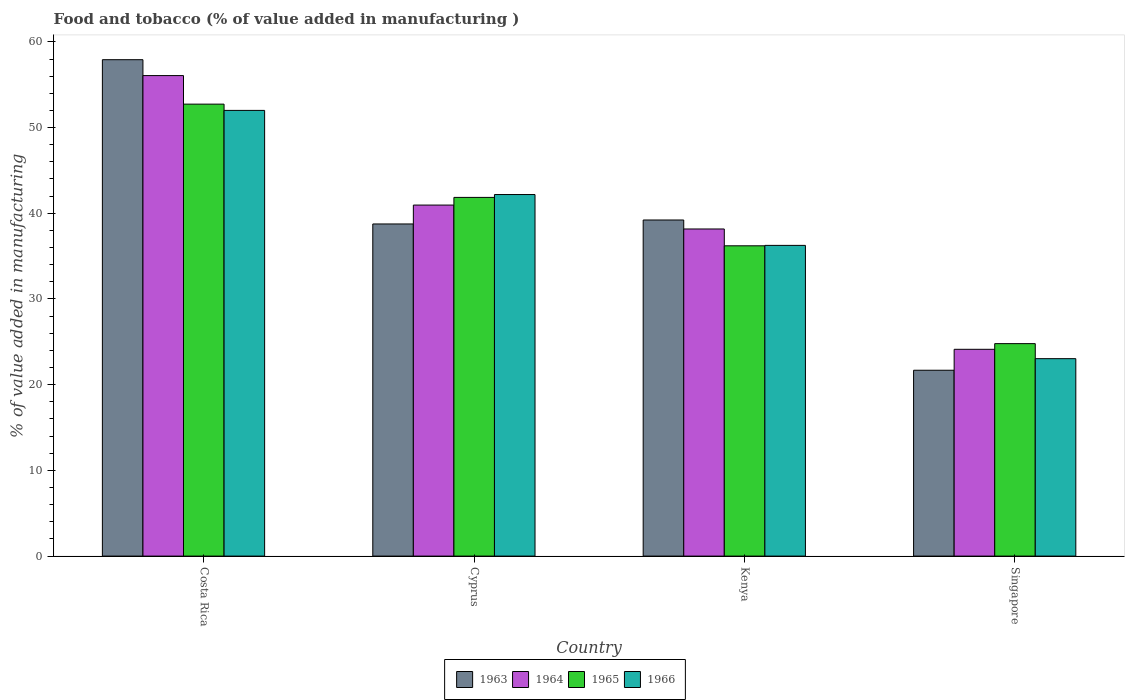How many different coloured bars are there?
Offer a very short reply. 4. How many groups of bars are there?
Keep it short and to the point. 4. Are the number of bars per tick equal to the number of legend labels?
Provide a short and direct response. Yes. How many bars are there on the 4th tick from the left?
Make the answer very short. 4. What is the label of the 3rd group of bars from the left?
Offer a very short reply. Kenya. In how many cases, is the number of bars for a given country not equal to the number of legend labels?
Your answer should be very brief. 0. What is the value added in manufacturing food and tobacco in 1966 in Costa Rica?
Offer a very short reply. 52. Across all countries, what is the maximum value added in manufacturing food and tobacco in 1963?
Your response must be concise. 57.92. Across all countries, what is the minimum value added in manufacturing food and tobacco in 1964?
Your answer should be very brief. 24.13. In which country was the value added in manufacturing food and tobacco in 1965 minimum?
Make the answer very short. Singapore. What is the total value added in manufacturing food and tobacco in 1964 in the graph?
Your answer should be very brief. 159.32. What is the difference between the value added in manufacturing food and tobacco in 1964 in Cyprus and that in Kenya?
Your answer should be compact. 2.79. What is the difference between the value added in manufacturing food and tobacco in 1964 in Singapore and the value added in manufacturing food and tobacco in 1966 in Costa Rica?
Ensure brevity in your answer.  -27.88. What is the average value added in manufacturing food and tobacco in 1964 per country?
Your response must be concise. 39.83. What is the difference between the value added in manufacturing food and tobacco of/in 1963 and value added in manufacturing food and tobacco of/in 1964 in Cyprus?
Offer a terse response. -2.2. In how many countries, is the value added in manufacturing food and tobacco in 1963 greater than 38 %?
Your answer should be compact. 3. What is the ratio of the value added in manufacturing food and tobacco in 1964 in Cyprus to that in Singapore?
Your answer should be very brief. 1.7. Is the value added in manufacturing food and tobacco in 1964 in Costa Rica less than that in Singapore?
Offer a terse response. No. What is the difference between the highest and the second highest value added in manufacturing food and tobacco in 1963?
Give a very brief answer. 19.17. What is the difference between the highest and the lowest value added in manufacturing food and tobacco in 1964?
Your answer should be very brief. 31.94. What does the 3rd bar from the left in Cyprus represents?
Make the answer very short. 1965. What does the 1st bar from the right in Costa Rica represents?
Provide a succinct answer. 1966. How many countries are there in the graph?
Offer a very short reply. 4. Are the values on the major ticks of Y-axis written in scientific E-notation?
Your answer should be compact. No. Does the graph contain any zero values?
Ensure brevity in your answer.  No. Does the graph contain grids?
Offer a terse response. No. How are the legend labels stacked?
Give a very brief answer. Horizontal. What is the title of the graph?
Ensure brevity in your answer.  Food and tobacco (% of value added in manufacturing ). Does "1979" appear as one of the legend labels in the graph?
Make the answer very short. No. What is the label or title of the Y-axis?
Provide a short and direct response. % of value added in manufacturing. What is the % of value added in manufacturing of 1963 in Costa Rica?
Provide a short and direct response. 57.92. What is the % of value added in manufacturing in 1964 in Costa Rica?
Offer a terse response. 56.07. What is the % of value added in manufacturing in 1965 in Costa Rica?
Offer a very short reply. 52.73. What is the % of value added in manufacturing of 1966 in Costa Rica?
Keep it short and to the point. 52. What is the % of value added in manufacturing of 1963 in Cyprus?
Provide a succinct answer. 38.75. What is the % of value added in manufacturing in 1964 in Cyprus?
Keep it short and to the point. 40.96. What is the % of value added in manufacturing in 1965 in Cyprus?
Keep it short and to the point. 41.85. What is the % of value added in manufacturing of 1966 in Cyprus?
Make the answer very short. 42.19. What is the % of value added in manufacturing of 1963 in Kenya?
Your response must be concise. 39.22. What is the % of value added in manufacturing in 1964 in Kenya?
Give a very brief answer. 38.17. What is the % of value added in manufacturing in 1965 in Kenya?
Provide a short and direct response. 36.2. What is the % of value added in manufacturing of 1966 in Kenya?
Your response must be concise. 36.25. What is the % of value added in manufacturing of 1963 in Singapore?
Your answer should be compact. 21.69. What is the % of value added in manufacturing of 1964 in Singapore?
Your answer should be compact. 24.13. What is the % of value added in manufacturing in 1965 in Singapore?
Give a very brief answer. 24.79. What is the % of value added in manufacturing in 1966 in Singapore?
Provide a short and direct response. 23.04. Across all countries, what is the maximum % of value added in manufacturing of 1963?
Provide a short and direct response. 57.92. Across all countries, what is the maximum % of value added in manufacturing of 1964?
Make the answer very short. 56.07. Across all countries, what is the maximum % of value added in manufacturing of 1965?
Your answer should be very brief. 52.73. Across all countries, what is the maximum % of value added in manufacturing in 1966?
Provide a succinct answer. 52. Across all countries, what is the minimum % of value added in manufacturing in 1963?
Ensure brevity in your answer.  21.69. Across all countries, what is the minimum % of value added in manufacturing in 1964?
Provide a succinct answer. 24.13. Across all countries, what is the minimum % of value added in manufacturing in 1965?
Ensure brevity in your answer.  24.79. Across all countries, what is the minimum % of value added in manufacturing in 1966?
Offer a terse response. 23.04. What is the total % of value added in manufacturing of 1963 in the graph?
Your answer should be compact. 157.58. What is the total % of value added in manufacturing in 1964 in the graph?
Offer a very short reply. 159.32. What is the total % of value added in manufacturing of 1965 in the graph?
Your answer should be compact. 155.58. What is the total % of value added in manufacturing in 1966 in the graph?
Provide a short and direct response. 153.48. What is the difference between the % of value added in manufacturing in 1963 in Costa Rica and that in Cyprus?
Ensure brevity in your answer.  19.17. What is the difference between the % of value added in manufacturing in 1964 in Costa Rica and that in Cyprus?
Offer a very short reply. 15.11. What is the difference between the % of value added in manufacturing of 1965 in Costa Rica and that in Cyprus?
Your answer should be compact. 10.88. What is the difference between the % of value added in manufacturing in 1966 in Costa Rica and that in Cyprus?
Provide a succinct answer. 9.82. What is the difference between the % of value added in manufacturing in 1963 in Costa Rica and that in Kenya?
Provide a short and direct response. 18.7. What is the difference between the % of value added in manufacturing in 1964 in Costa Rica and that in Kenya?
Your answer should be very brief. 17.9. What is the difference between the % of value added in manufacturing of 1965 in Costa Rica and that in Kenya?
Offer a terse response. 16.53. What is the difference between the % of value added in manufacturing of 1966 in Costa Rica and that in Kenya?
Make the answer very short. 15.75. What is the difference between the % of value added in manufacturing of 1963 in Costa Rica and that in Singapore?
Give a very brief answer. 36.23. What is the difference between the % of value added in manufacturing in 1964 in Costa Rica and that in Singapore?
Provide a short and direct response. 31.94. What is the difference between the % of value added in manufacturing in 1965 in Costa Rica and that in Singapore?
Ensure brevity in your answer.  27.94. What is the difference between the % of value added in manufacturing of 1966 in Costa Rica and that in Singapore?
Make the answer very short. 28.97. What is the difference between the % of value added in manufacturing in 1963 in Cyprus and that in Kenya?
Your answer should be very brief. -0.46. What is the difference between the % of value added in manufacturing in 1964 in Cyprus and that in Kenya?
Keep it short and to the point. 2.79. What is the difference between the % of value added in manufacturing of 1965 in Cyprus and that in Kenya?
Your response must be concise. 5.65. What is the difference between the % of value added in manufacturing in 1966 in Cyprus and that in Kenya?
Make the answer very short. 5.93. What is the difference between the % of value added in manufacturing in 1963 in Cyprus and that in Singapore?
Provide a succinct answer. 17.07. What is the difference between the % of value added in manufacturing of 1964 in Cyprus and that in Singapore?
Ensure brevity in your answer.  16.83. What is the difference between the % of value added in manufacturing of 1965 in Cyprus and that in Singapore?
Ensure brevity in your answer.  17.06. What is the difference between the % of value added in manufacturing in 1966 in Cyprus and that in Singapore?
Your answer should be compact. 19.15. What is the difference between the % of value added in manufacturing of 1963 in Kenya and that in Singapore?
Make the answer very short. 17.53. What is the difference between the % of value added in manufacturing in 1964 in Kenya and that in Singapore?
Your answer should be compact. 14.04. What is the difference between the % of value added in manufacturing in 1965 in Kenya and that in Singapore?
Your response must be concise. 11.41. What is the difference between the % of value added in manufacturing in 1966 in Kenya and that in Singapore?
Ensure brevity in your answer.  13.22. What is the difference between the % of value added in manufacturing in 1963 in Costa Rica and the % of value added in manufacturing in 1964 in Cyprus?
Your answer should be compact. 16.96. What is the difference between the % of value added in manufacturing of 1963 in Costa Rica and the % of value added in manufacturing of 1965 in Cyprus?
Make the answer very short. 16.07. What is the difference between the % of value added in manufacturing in 1963 in Costa Rica and the % of value added in manufacturing in 1966 in Cyprus?
Your answer should be very brief. 15.73. What is the difference between the % of value added in manufacturing of 1964 in Costa Rica and the % of value added in manufacturing of 1965 in Cyprus?
Offer a very short reply. 14.21. What is the difference between the % of value added in manufacturing in 1964 in Costa Rica and the % of value added in manufacturing in 1966 in Cyprus?
Offer a terse response. 13.88. What is the difference between the % of value added in manufacturing in 1965 in Costa Rica and the % of value added in manufacturing in 1966 in Cyprus?
Ensure brevity in your answer.  10.55. What is the difference between the % of value added in manufacturing in 1963 in Costa Rica and the % of value added in manufacturing in 1964 in Kenya?
Provide a succinct answer. 19.75. What is the difference between the % of value added in manufacturing of 1963 in Costa Rica and the % of value added in manufacturing of 1965 in Kenya?
Provide a succinct answer. 21.72. What is the difference between the % of value added in manufacturing in 1963 in Costa Rica and the % of value added in manufacturing in 1966 in Kenya?
Ensure brevity in your answer.  21.67. What is the difference between the % of value added in manufacturing of 1964 in Costa Rica and the % of value added in manufacturing of 1965 in Kenya?
Provide a succinct answer. 19.86. What is the difference between the % of value added in manufacturing in 1964 in Costa Rica and the % of value added in manufacturing in 1966 in Kenya?
Offer a very short reply. 19.81. What is the difference between the % of value added in manufacturing of 1965 in Costa Rica and the % of value added in manufacturing of 1966 in Kenya?
Offer a terse response. 16.48. What is the difference between the % of value added in manufacturing in 1963 in Costa Rica and the % of value added in manufacturing in 1964 in Singapore?
Ensure brevity in your answer.  33.79. What is the difference between the % of value added in manufacturing of 1963 in Costa Rica and the % of value added in manufacturing of 1965 in Singapore?
Offer a terse response. 33.13. What is the difference between the % of value added in manufacturing of 1963 in Costa Rica and the % of value added in manufacturing of 1966 in Singapore?
Offer a terse response. 34.88. What is the difference between the % of value added in manufacturing of 1964 in Costa Rica and the % of value added in manufacturing of 1965 in Singapore?
Provide a succinct answer. 31.28. What is the difference between the % of value added in manufacturing of 1964 in Costa Rica and the % of value added in manufacturing of 1966 in Singapore?
Give a very brief answer. 33.03. What is the difference between the % of value added in manufacturing of 1965 in Costa Rica and the % of value added in manufacturing of 1966 in Singapore?
Your answer should be very brief. 29.7. What is the difference between the % of value added in manufacturing in 1963 in Cyprus and the % of value added in manufacturing in 1964 in Kenya?
Make the answer very short. 0.59. What is the difference between the % of value added in manufacturing in 1963 in Cyprus and the % of value added in manufacturing in 1965 in Kenya?
Your answer should be very brief. 2.55. What is the difference between the % of value added in manufacturing of 1963 in Cyprus and the % of value added in manufacturing of 1966 in Kenya?
Make the answer very short. 2.5. What is the difference between the % of value added in manufacturing in 1964 in Cyprus and the % of value added in manufacturing in 1965 in Kenya?
Make the answer very short. 4.75. What is the difference between the % of value added in manufacturing in 1964 in Cyprus and the % of value added in manufacturing in 1966 in Kenya?
Make the answer very short. 4.7. What is the difference between the % of value added in manufacturing in 1965 in Cyprus and the % of value added in manufacturing in 1966 in Kenya?
Keep it short and to the point. 5.6. What is the difference between the % of value added in manufacturing in 1963 in Cyprus and the % of value added in manufacturing in 1964 in Singapore?
Keep it short and to the point. 14.63. What is the difference between the % of value added in manufacturing in 1963 in Cyprus and the % of value added in manufacturing in 1965 in Singapore?
Your answer should be very brief. 13.96. What is the difference between the % of value added in manufacturing of 1963 in Cyprus and the % of value added in manufacturing of 1966 in Singapore?
Make the answer very short. 15.72. What is the difference between the % of value added in manufacturing of 1964 in Cyprus and the % of value added in manufacturing of 1965 in Singapore?
Provide a succinct answer. 16.17. What is the difference between the % of value added in manufacturing in 1964 in Cyprus and the % of value added in manufacturing in 1966 in Singapore?
Keep it short and to the point. 17.92. What is the difference between the % of value added in manufacturing of 1965 in Cyprus and the % of value added in manufacturing of 1966 in Singapore?
Your answer should be very brief. 18.82. What is the difference between the % of value added in manufacturing in 1963 in Kenya and the % of value added in manufacturing in 1964 in Singapore?
Offer a terse response. 15.09. What is the difference between the % of value added in manufacturing in 1963 in Kenya and the % of value added in manufacturing in 1965 in Singapore?
Provide a succinct answer. 14.43. What is the difference between the % of value added in manufacturing of 1963 in Kenya and the % of value added in manufacturing of 1966 in Singapore?
Provide a short and direct response. 16.18. What is the difference between the % of value added in manufacturing of 1964 in Kenya and the % of value added in manufacturing of 1965 in Singapore?
Your answer should be very brief. 13.38. What is the difference between the % of value added in manufacturing in 1964 in Kenya and the % of value added in manufacturing in 1966 in Singapore?
Your answer should be compact. 15.13. What is the difference between the % of value added in manufacturing in 1965 in Kenya and the % of value added in manufacturing in 1966 in Singapore?
Make the answer very short. 13.17. What is the average % of value added in manufacturing in 1963 per country?
Offer a terse response. 39.39. What is the average % of value added in manufacturing of 1964 per country?
Provide a short and direct response. 39.83. What is the average % of value added in manufacturing in 1965 per country?
Your answer should be compact. 38.9. What is the average % of value added in manufacturing in 1966 per country?
Provide a succinct answer. 38.37. What is the difference between the % of value added in manufacturing of 1963 and % of value added in manufacturing of 1964 in Costa Rica?
Your answer should be compact. 1.85. What is the difference between the % of value added in manufacturing in 1963 and % of value added in manufacturing in 1965 in Costa Rica?
Your answer should be very brief. 5.19. What is the difference between the % of value added in manufacturing of 1963 and % of value added in manufacturing of 1966 in Costa Rica?
Your response must be concise. 5.92. What is the difference between the % of value added in manufacturing of 1964 and % of value added in manufacturing of 1965 in Costa Rica?
Make the answer very short. 3.33. What is the difference between the % of value added in manufacturing in 1964 and % of value added in manufacturing in 1966 in Costa Rica?
Your answer should be very brief. 4.06. What is the difference between the % of value added in manufacturing of 1965 and % of value added in manufacturing of 1966 in Costa Rica?
Make the answer very short. 0.73. What is the difference between the % of value added in manufacturing in 1963 and % of value added in manufacturing in 1964 in Cyprus?
Your answer should be compact. -2.2. What is the difference between the % of value added in manufacturing of 1963 and % of value added in manufacturing of 1965 in Cyprus?
Provide a short and direct response. -3.1. What is the difference between the % of value added in manufacturing of 1963 and % of value added in manufacturing of 1966 in Cyprus?
Keep it short and to the point. -3.43. What is the difference between the % of value added in manufacturing of 1964 and % of value added in manufacturing of 1965 in Cyprus?
Offer a terse response. -0.9. What is the difference between the % of value added in manufacturing in 1964 and % of value added in manufacturing in 1966 in Cyprus?
Provide a succinct answer. -1.23. What is the difference between the % of value added in manufacturing in 1965 and % of value added in manufacturing in 1966 in Cyprus?
Provide a short and direct response. -0.33. What is the difference between the % of value added in manufacturing of 1963 and % of value added in manufacturing of 1964 in Kenya?
Your answer should be compact. 1.05. What is the difference between the % of value added in manufacturing of 1963 and % of value added in manufacturing of 1965 in Kenya?
Your answer should be compact. 3.01. What is the difference between the % of value added in manufacturing in 1963 and % of value added in manufacturing in 1966 in Kenya?
Offer a very short reply. 2.96. What is the difference between the % of value added in manufacturing of 1964 and % of value added in manufacturing of 1965 in Kenya?
Provide a short and direct response. 1.96. What is the difference between the % of value added in manufacturing of 1964 and % of value added in manufacturing of 1966 in Kenya?
Provide a succinct answer. 1.91. What is the difference between the % of value added in manufacturing of 1963 and % of value added in manufacturing of 1964 in Singapore?
Ensure brevity in your answer.  -2.44. What is the difference between the % of value added in manufacturing of 1963 and % of value added in manufacturing of 1965 in Singapore?
Offer a very short reply. -3.1. What is the difference between the % of value added in manufacturing in 1963 and % of value added in manufacturing in 1966 in Singapore?
Provide a short and direct response. -1.35. What is the difference between the % of value added in manufacturing of 1964 and % of value added in manufacturing of 1965 in Singapore?
Keep it short and to the point. -0.66. What is the difference between the % of value added in manufacturing in 1964 and % of value added in manufacturing in 1966 in Singapore?
Provide a succinct answer. 1.09. What is the difference between the % of value added in manufacturing of 1965 and % of value added in manufacturing of 1966 in Singapore?
Provide a short and direct response. 1.75. What is the ratio of the % of value added in manufacturing in 1963 in Costa Rica to that in Cyprus?
Offer a very short reply. 1.49. What is the ratio of the % of value added in manufacturing in 1964 in Costa Rica to that in Cyprus?
Make the answer very short. 1.37. What is the ratio of the % of value added in manufacturing of 1965 in Costa Rica to that in Cyprus?
Your response must be concise. 1.26. What is the ratio of the % of value added in manufacturing in 1966 in Costa Rica to that in Cyprus?
Ensure brevity in your answer.  1.23. What is the ratio of the % of value added in manufacturing in 1963 in Costa Rica to that in Kenya?
Provide a succinct answer. 1.48. What is the ratio of the % of value added in manufacturing of 1964 in Costa Rica to that in Kenya?
Provide a succinct answer. 1.47. What is the ratio of the % of value added in manufacturing of 1965 in Costa Rica to that in Kenya?
Offer a terse response. 1.46. What is the ratio of the % of value added in manufacturing of 1966 in Costa Rica to that in Kenya?
Provide a short and direct response. 1.43. What is the ratio of the % of value added in manufacturing in 1963 in Costa Rica to that in Singapore?
Your response must be concise. 2.67. What is the ratio of the % of value added in manufacturing in 1964 in Costa Rica to that in Singapore?
Your answer should be very brief. 2.32. What is the ratio of the % of value added in manufacturing in 1965 in Costa Rica to that in Singapore?
Ensure brevity in your answer.  2.13. What is the ratio of the % of value added in manufacturing of 1966 in Costa Rica to that in Singapore?
Offer a very short reply. 2.26. What is the ratio of the % of value added in manufacturing in 1964 in Cyprus to that in Kenya?
Your answer should be very brief. 1.07. What is the ratio of the % of value added in manufacturing in 1965 in Cyprus to that in Kenya?
Provide a succinct answer. 1.16. What is the ratio of the % of value added in manufacturing in 1966 in Cyprus to that in Kenya?
Make the answer very short. 1.16. What is the ratio of the % of value added in manufacturing of 1963 in Cyprus to that in Singapore?
Ensure brevity in your answer.  1.79. What is the ratio of the % of value added in manufacturing of 1964 in Cyprus to that in Singapore?
Offer a terse response. 1.7. What is the ratio of the % of value added in manufacturing in 1965 in Cyprus to that in Singapore?
Your answer should be very brief. 1.69. What is the ratio of the % of value added in manufacturing in 1966 in Cyprus to that in Singapore?
Provide a succinct answer. 1.83. What is the ratio of the % of value added in manufacturing in 1963 in Kenya to that in Singapore?
Provide a short and direct response. 1.81. What is the ratio of the % of value added in manufacturing of 1964 in Kenya to that in Singapore?
Keep it short and to the point. 1.58. What is the ratio of the % of value added in manufacturing in 1965 in Kenya to that in Singapore?
Your answer should be compact. 1.46. What is the ratio of the % of value added in manufacturing in 1966 in Kenya to that in Singapore?
Make the answer very short. 1.57. What is the difference between the highest and the second highest % of value added in manufacturing of 1963?
Offer a terse response. 18.7. What is the difference between the highest and the second highest % of value added in manufacturing of 1964?
Offer a terse response. 15.11. What is the difference between the highest and the second highest % of value added in manufacturing of 1965?
Provide a succinct answer. 10.88. What is the difference between the highest and the second highest % of value added in manufacturing of 1966?
Provide a succinct answer. 9.82. What is the difference between the highest and the lowest % of value added in manufacturing in 1963?
Offer a terse response. 36.23. What is the difference between the highest and the lowest % of value added in manufacturing of 1964?
Make the answer very short. 31.94. What is the difference between the highest and the lowest % of value added in manufacturing of 1965?
Offer a very short reply. 27.94. What is the difference between the highest and the lowest % of value added in manufacturing of 1966?
Your answer should be compact. 28.97. 